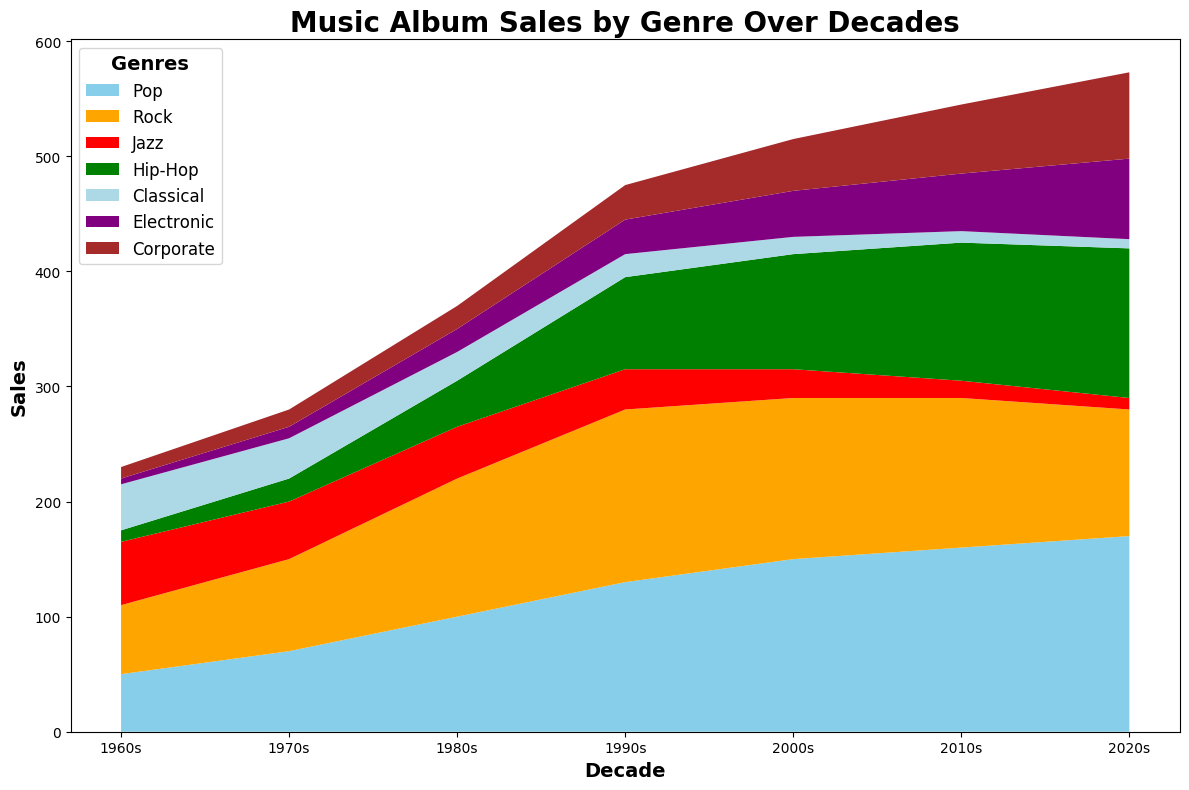What's the general trend in Corporate music sales over the decades? By observing the area chart, we see that the Corporate genre area steadily increases over the decades, indicating a rise in sales from the 1960s to the 2020s.
Answer: Increasing Has Jazz sales increased or decreased from the 1960s to the 2020s? The area representing Jazz sales declines over time from a peak in the 1960s to much lower in the 2020s.
Answer: Decreased During which decade did Hip-Hop sales surpass Jazz sales for the first time? By examining the areas between the genres, Hip-Hop overtakes Jazz in sales during the 1980s.
Answer: 1980s Compare the sales of Rock and Classical genres in the 1990s. Which was higher and by how much? In the 1990s, Rock had 150 in sales, while Classical had 20 in sales. The difference is 150 - 20 = 130.
Answer: Rock, by 130 Across all decades, which genre shows the most significant increase in sales? Hip-Hop shows the most significant increase, starting from 10 in the 1960s to 130 in the 2020s.
Answer: Hip-Hop What is the common trend for the Classical genre from 1960s to 2020s? Classical music sales show a consistent decline over the decades from 40 to 8.
Answer: Declining How does the trend in Pop music sales compare to Corporate music sales in the 2010s and 2020s? In the 2010s and 2020s, Pop sales increase slightly, whereas Corporate sales rise dramatically, catching up to other genres.
Answer: Corporate rises faster In the 2000s, what is the sum of sales for all the genres? Sum the sales for all genres in the 2000s: 150 (Pop) + 140 (Rock) + 25 (Jazz) + 100 (Hip-Hop) + 15 (Classical) + 40 (Electronic) + 45 (Corporate) = 515.
Answer: 515 In which decade did Electronic music experience the steepest growth in sales? Electronic music shows consistent growth but the most noticeable increase happened from the 2010s to 2020s, rising from 50 to 70.
Answer: 2010s to 2020s Compare the sales of Jazz and Corporate music in the 2020s. Which is higher and by how much? In the 2020s, Jazz has 10 in sales, and Corporate has 75. The difference is 75 - 10 = 65.
Answer: Corporate, by 65 